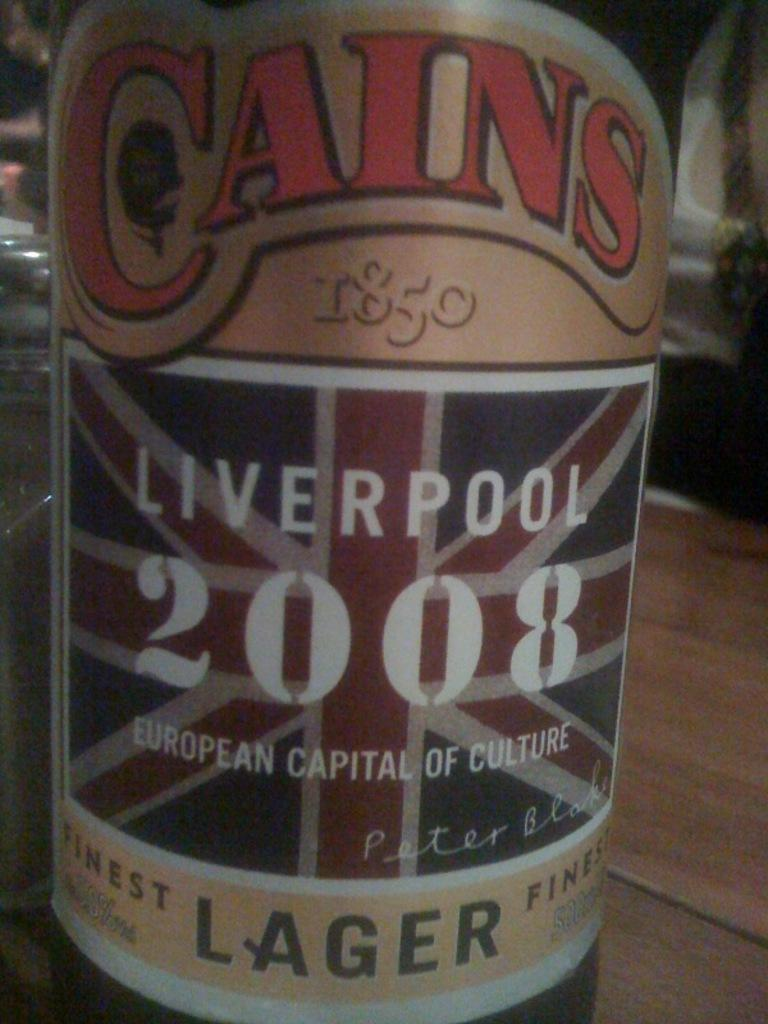<image>
Write a terse but informative summary of the picture. A bottle of 2008 Cains Lager is shown up close with its label in front. 